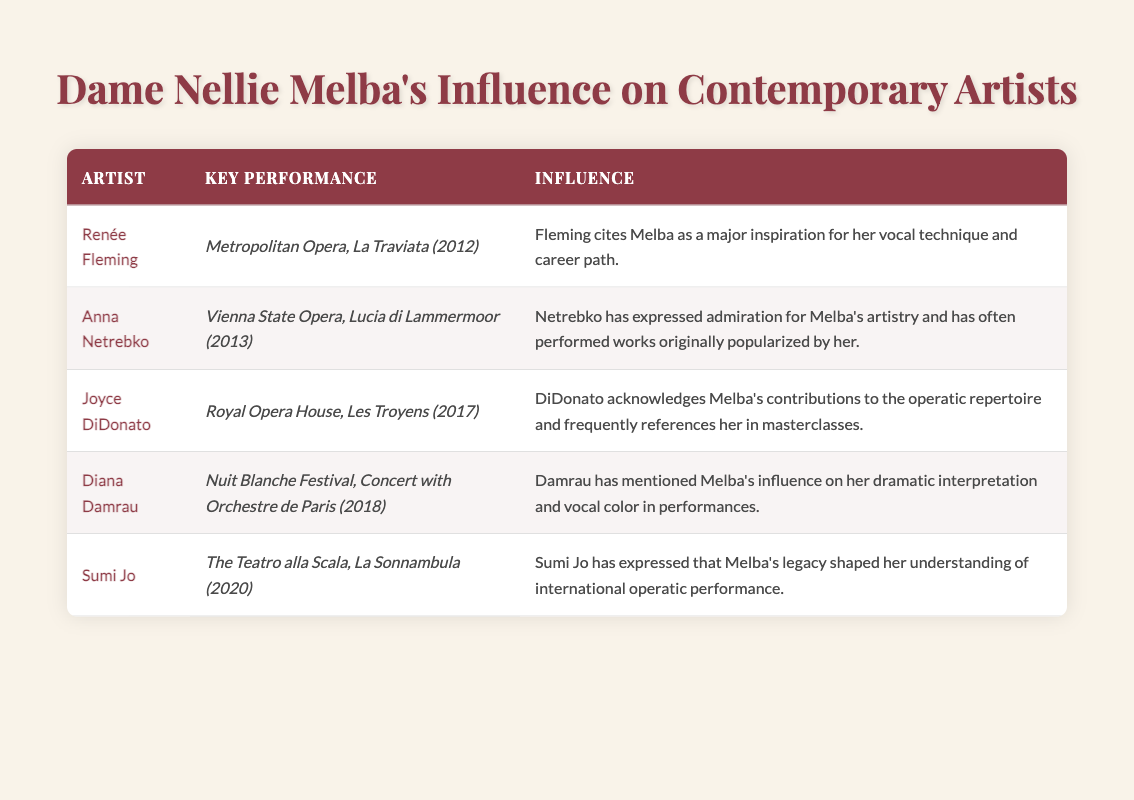What is the key performance by Renée Fleming? According to the table, the key performance by Renée Fleming is "Metropolitan Opera, La Traviata (2012)." This information is found in the row corresponding to her name.
Answer: Metropolitan Opera, La Traviata (2012) Which artist performed at the Royal Opera House in 2017? The table shows that Joyce DiDonato is the artist who performed at the Royal Opera House in 2017, specifically in the production of "Les Troyens." This can be directly identified in the relevant row.
Answer: Joyce DiDonato Has Anna Netrebko performed works originally popularized by Melba? Yes, the table indicates that Anna Netrebko has expressed admiration for Melba's artistry and has often performed works originally popularized by her. This is stated clearly in her influence description.
Answer: Yes What is the influence attributed to Diana Damrau regarding Melba? The table details that Diana Damrau has mentioned Melba's influence on her dramatic interpretation and vocal color in performances. This information is directly taken from the row associated with her name.
Answer: Melba's influence on her dramatic interpretation and vocal color Count how many artists cited Melba as an influence and also performed at prestigious venues. There are 5 artists listed, and all of them performed at prestigious venues: Renée Fleming, Anna Netrebko, Joyce DiDonato, Diana Damrau, and Sumi Jo. Each artist's performance is associated with a significant opera house or venue, indicating they all meet this criterion. Therefore, the count is 5.
Answer: 5 